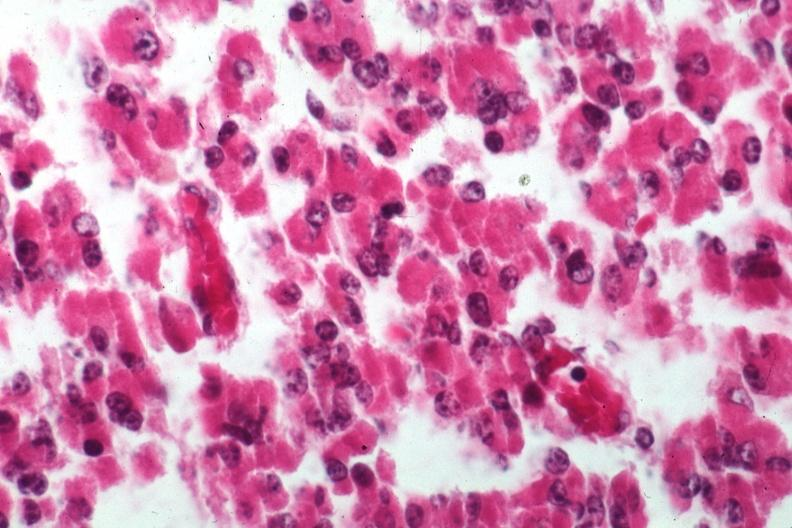s fat necrosis present?
Answer the question using a single word or phrase. No 